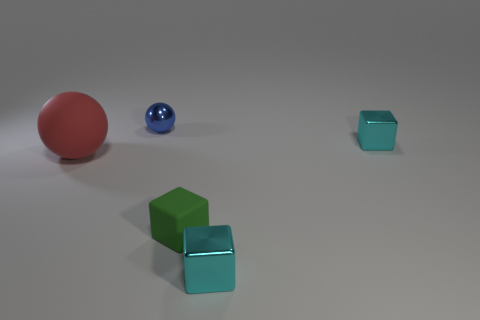Subtract all red cylinders. How many cyan blocks are left? 2 Subtract 1 blocks. How many blocks are left? 2 Add 1 matte cubes. How many objects exist? 6 Subtract all cubes. How many objects are left? 2 Add 4 metal spheres. How many metal spheres are left? 5 Add 1 small yellow rubber objects. How many small yellow rubber objects exist? 1 Subtract 0 green cylinders. How many objects are left? 5 Subtract all small green objects. Subtract all tiny yellow rubber things. How many objects are left? 4 